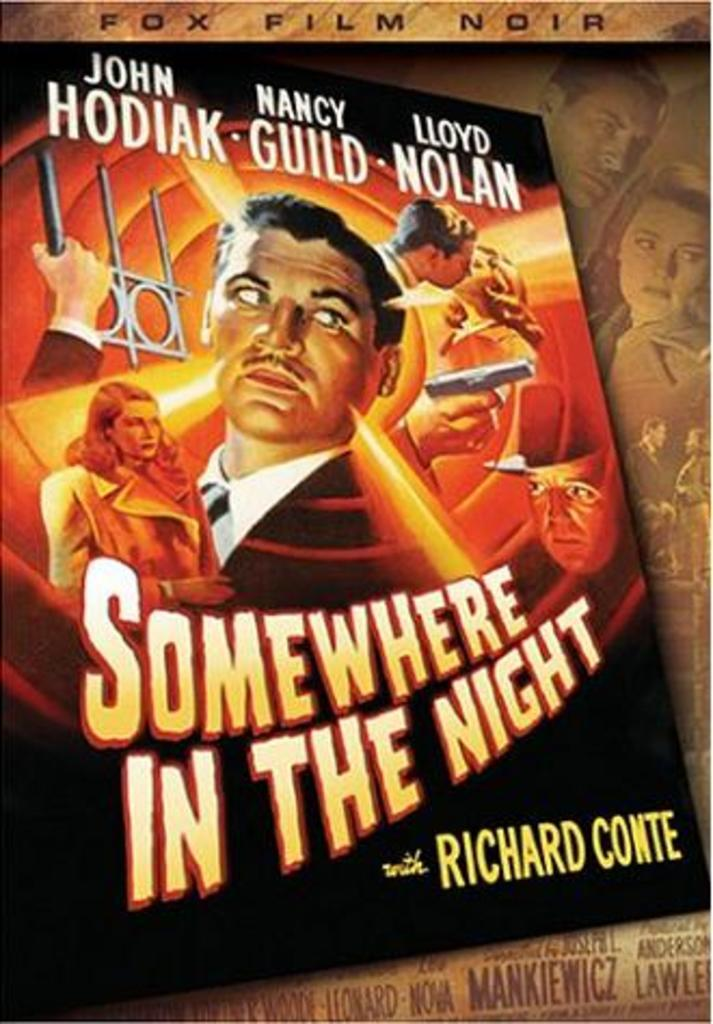<image>
Give a short and clear explanation of the subsequent image. A movie poster for a fox film noir called Somewhere in the night. 